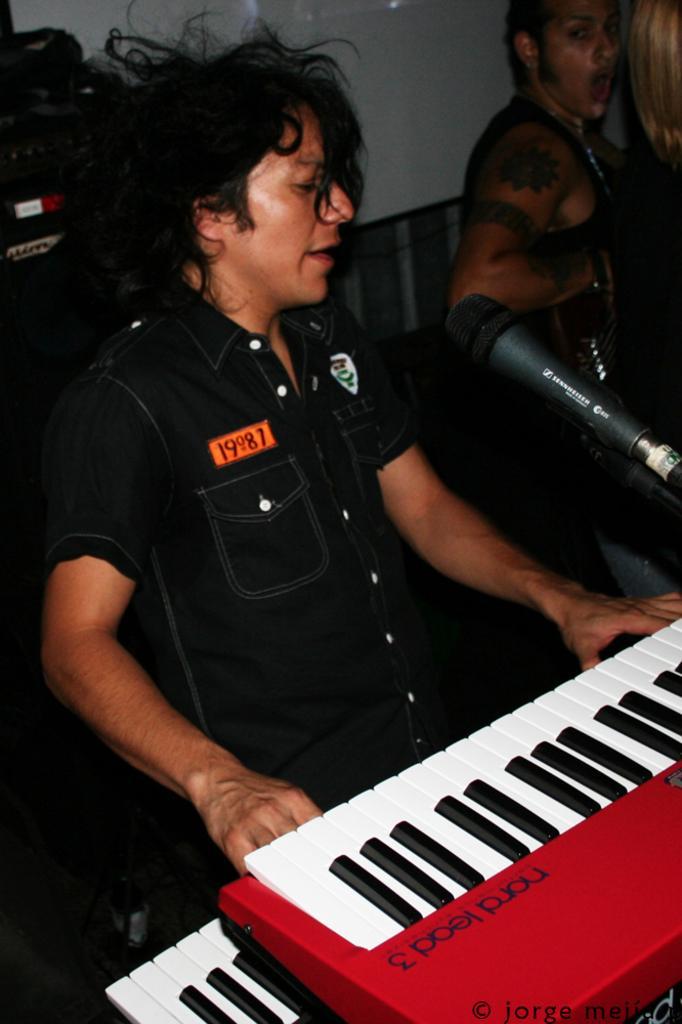Can you describe this image briefly? In this image we can see a person sitting on a chair. He is playing a piano and singing on a microphone. Here we can see a person and he is on the top right side. 